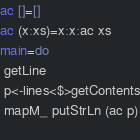<code> <loc_0><loc_0><loc_500><loc_500><_Haskell_>ac []=[]
ac (x:xs)=x:x:ac xs
main=do
 getLine
 p<-lines<$>getContents
 mapM_ putStrLn (ac p)
 </code> 